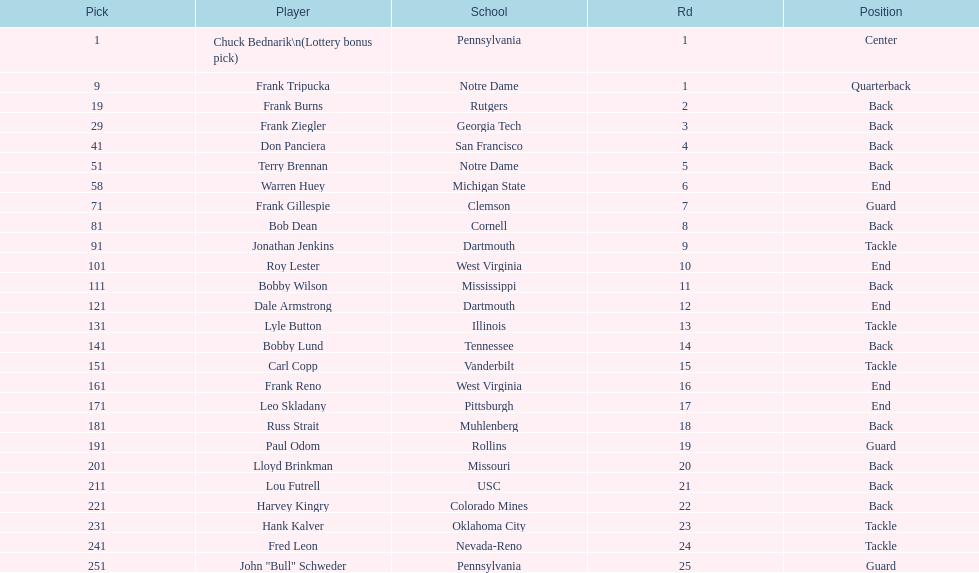Who was the player that the team drafted after bob dean? Jonathan Jenkins. Could you parse the entire table as a dict? {'header': ['Pick', 'Player', 'School', 'Rd', 'Position'], 'rows': [['1', 'Chuck Bednarik\\n(Lottery bonus pick)', 'Pennsylvania', '1', 'Center'], ['9', 'Frank Tripucka', 'Notre Dame', '1', 'Quarterback'], ['19', 'Frank Burns', 'Rutgers', '2', 'Back'], ['29', 'Frank Ziegler', 'Georgia Tech', '3', 'Back'], ['41', 'Don Panciera', 'San Francisco', '4', 'Back'], ['51', 'Terry Brennan', 'Notre Dame', '5', 'Back'], ['58', 'Warren Huey', 'Michigan State', '6', 'End'], ['71', 'Frank Gillespie', 'Clemson', '7', 'Guard'], ['81', 'Bob Dean', 'Cornell', '8', 'Back'], ['91', 'Jonathan Jenkins', 'Dartmouth', '9', 'Tackle'], ['101', 'Roy Lester', 'West Virginia', '10', 'End'], ['111', 'Bobby Wilson', 'Mississippi', '11', 'Back'], ['121', 'Dale Armstrong', 'Dartmouth', '12', 'End'], ['131', 'Lyle Button', 'Illinois', '13', 'Tackle'], ['141', 'Bobby Lund', 'Tennessee', '14', 'Back'], ['151', 'Carl Copp', 'Vanderbilt', '15', 'Tackle'], ['161', 'Frank Reno', 'West Virginia', '16', 'End'], ['171', 'Leo Skladany', 'Pittsburgh', '17', 'End'], ['181', 'Russ Strait', 'Muhlenberg', '18', 'Back'], ['191', 'Paul Odom', 'Rollins', '19', 'Guard'], ['201', 'Lloyd Brinkman', 'Missouri', '20', 'Back'], ['211', 'Lou Futrell', 'USC', '21', 'Back'], ['221', 'Harvey Kingry', 'Colorado Mines', '22', 'Back'], ['231', 'Hank Kalver', 'Oklahoma City', '23', 'Tackle'], ['241', 'Fred Leon', 'Nevada-Reno', '24', 'Tackle'], ['251', 'John "Bull" Schweder', 'Pennsylvania', '25', 'Guard']]} 